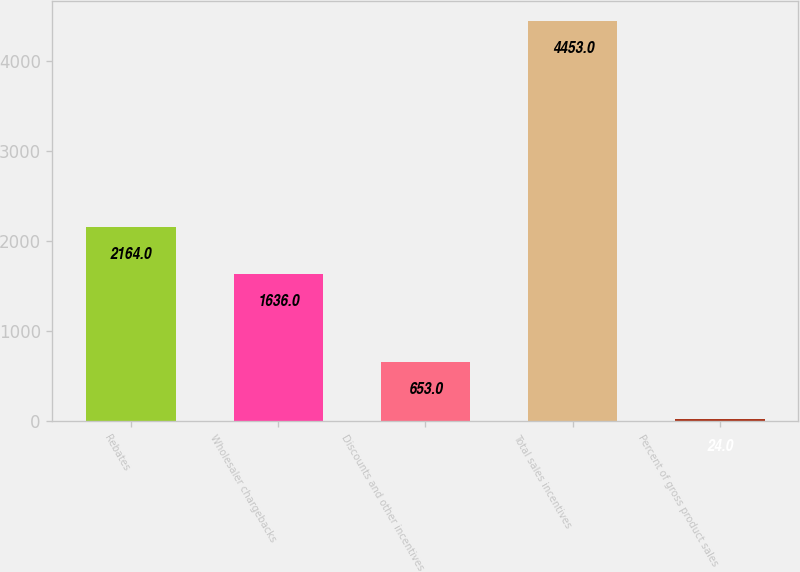<chart> <loc_0><loc_0><loc_500><loc_500><bar_chart><fcel>Rebates<fcel>Wholesaler chargebacks<fcel>Discounts and other incentives<fcel>Total sales incentives<fcel>Percent of gross product sales<nl><fcel>2164<fcel>1636<fcel>653<fcel>4453<fcel>24<nl></chart> 